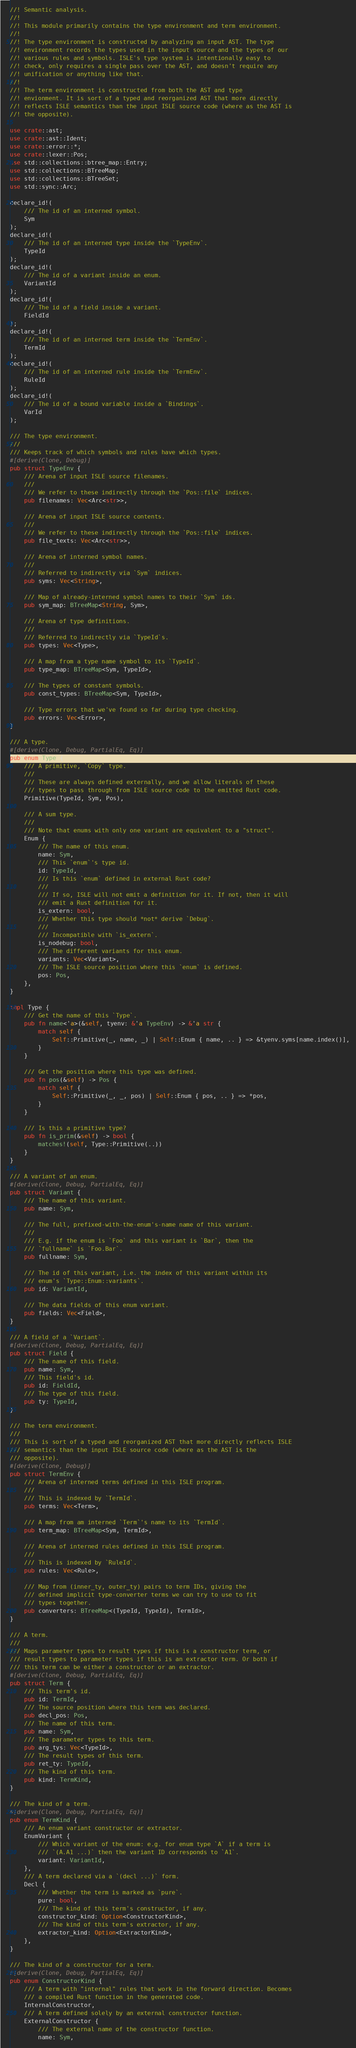Convert code to text. <code><loc_0><loc_0><loc_500><loc_500><_Rust_>//! Semantic analysis.
//!
//! This module primarily contains the type environment and term environment.
//!
//! The type environment is constructed by analyzing an input AST. The type
//! environment records the types used in the input source and the types of our
//! various rules and symbols. ISLE's type system is intentionally easy to
//! check, only requires a single pass over the AST, and doesn't require any
//! unification or anything like that.
//!
//! The term environment is constructed from both the AST and type
//! envionment. It is sort of a typed and reorganized AST that more directly
//! reflects ISLE semantics than the input ISLE source code (where as the AST is
//! the opposite).

use crate::ast;
use crate::ast::Ident;
use crate::error::*;
use crate::lexer::Pos;
use std::collections::btree_map::Entry;
use std::collections::BTreeMap;
use std::collections::BTreeSet;
use std::sync::Arc;

declare_id!(
    /// The id of an interned symbol.
    Sym
);
declare_id!(
    /// The id of an interned type inside the `TypeEnv`.
    TypeId
);
declare_id!(
    /// The id of a variant inside an enum.
    VariantId
);
declare_id!(
    /// The id of a field inside a variant.
    FieldId
);
declare_id!(
    /// The id of an interned term inside the `TermEnv`.
    TermId
);
declare_id!(
    /// The id of an interned rule inside the `TermEnv`.
    RuleId
);
declare_id!(
    /// The id of a bound variable inside a `Bindings`.
    VarId
);

/// The type environment.
///
/// Keeps track of which symbols and rules have which types.
#[derive(Clone, Debug)]
pub struct TypeEnv {
    /// Arena of input ISLE source filenames.
    ///
    /// We refer to these indirectly through the `Pos::file` indices.
    pub filenames: Vec<Arc<str>>,

    /// Arena of input ISLE source contents.
    ///
    /// We refer to these indirectly through the `Pos::file` indices.
    pub file_texts: Vec<Arc<str>>,

    /// Arena of interned symbol names.
    ///
    /// Referred to indirectly via `Sym` indices.
    pub syms: Vec<String>,

    /// Map of already-interned symbol names to their `Sym` ids.
    pub sym_map: BTreeMap<String, Sym>,

    /// Arena of type definitions.
    ///
    /// Referred to indirectly via `TypeId`s.
    pub types: Vec<Type>,

    /// A map from a type name symbol to its `TypeId`.
    pub type_map: BTreeMap<Sym, TypeId>,

    /// The types of constant symbols.
    pub const_types: BTreeMap<Sym, TypeId>,

    /// Type errors that we've found so far during type checking.
    pub errors: Vec<Error>,
}

/// A type.
#[derive(Clone, Debug, PartialEq, Eq)]
pub enum Type {
    /// A primitive, `Copy` type.
    ///
    /// These are always defined externally, and we allow literals of these
    /// types to pass through from ISLE source code to the emitted Rust code.
    Primitive(TypeId, Sym, Pos),

    /// A sum type.
    ///
    /// Note that enums with only one variant are equivalent to a "struct".
    Enum {
        /// The name of this enum.
        name: Sym,
        /// This `enum`'s type id.
        id: TypeId,
        /// Is this `enum` defined in external Rust code?
        ///
        /// If so, ISLE will not emit a definition for it. If not, then it will
        /// emit a Rust definition for it.
        is_extern: bool,
        /// Whether this type should *not* derive `Debug`.
        ///
        /// Incompatible with `is_extern`.
        is_nodebug: bool,
        /// The different variants for this enum.
        variants: Vec<Variant>,
        /// The ISLE source position where this `enum` is defined.
        pos: Pos,
    },
}

impl Type {
    /// Get the name of this `Type`.
    pub fn name<'a>(&self, tyenv: &'a TypeEnv) -> &'a str {
        match self {
            Self::Primitive(_, name, _) | Self::Enum { name, .. } => &tyenv.syms[name.index()],
        }
    }

    /// Get the position where this type was defined.
    pub fn pos(&self) -> Pos {
        match self {
            Self::Primitive(_, _, pos) | Self::Enum { pos, .. } => *pos,
        }
    }

    /// Is this a primitive type?
    pub fn is_prim(&self) -> bool {
        matches!(self, Type::Primitive(..))
    }
}

/// A variant of an enum.
#[derive(Clone, Debug, PartialEq, Eq)]
pub struct Variant {
    /// The name of this variant.
    pub name: Sym,

    /// The full, prefixed-with-the-enum's-name name of this variant.
    ///
    /// E.g. if the enum is `Foo` and this variant is `Bar`, then the
    /// `fullname` is `Foo.Bar`.
    pub fullname: Sym,

    /// The id of this variant, i.e. the index of this variant within its
    /// enum's `Type::Enum::variants`.
    pub id: VariantId,

    /// The data fields of this enum variant.
    pub fields: Vec<Field>,
}

/// A field of a `Variant`.
#[derive(Clone, Debug, PartialEq, Eq)]
pub struct Field {
    /// The name of this field.
    pub name: Sym,
    /// This field's id.
    pub id: FieldId,
    /// The type of this field.
    pub ty: TypeId,
}

/// The term environment.
///
/// This is sort of a typed and reorganized AST that more directly reflects ISLE
/// semantics than the input ISLE source code (where as the AST is the
/// opposite).
#[derive(Clone, Debug)]
pub struct TermEnv {
    /// Arena of interned terms defined in this ISLE program.
    ///
    /// This is indexed by `TermId`.
    pub terms: Vec<Term>,

    /// A map from am interned `Term`'s name to its `TermId`.
    pub term_map: BTreeMap<Sym, TermId>,

    /// Arena of interned rules defined in this ISLE program.
    ///
    /// This is indexed by `RuleId`.
    pub rules: Vec<Rule>,

    /// Map from (inner_ty, outer_ty) pairs to term IDs, giving the
    /// defined implicit type-converter terms we can try to use to fit
    /// types together.
    pub converters: BTreeMap<(TypeId, TypeId), TermId>,
}

/// A term.
///
/// Maps parameter types to result types if this is a constructor term, or
/// result types to parameter types if this is an extractor term. Or both if
/// this term can be either a constructor or an extractor.
#[derive(Clone, Debug, PartialEq, Eq)]
pub struct Term {
    /// This term's id.
    pub id: TermId,
    /// The source position where this term was declared.
    pub decl_pos: Pos,
    /// The name of this term.
    pub name: Sym,
    /// The parameter types to this term.
    pub arg_tys: Vec<TypeId>,
    /// The result types of this term.
    pub ret_ty: TypeId,
    /// The kind of this term.
    pub kind: TermKind,
}

/// The kind of a term.
#[derive(Clone, Debug, PartialEq, Eq)]
pub enum TermKind {
    /// An enum variant constructor or extractor.
    EnumVariant {
        /// Which variant of the enum: e.g. for enum type `A` if a term is
        /// `(A.A1 ...)` then the variant ID corresponds to `A1`.
        variant: VariantId,
    },
    /// A term declared via a `(decl ...)` form.
    Decl {
        /// Whether the term is marked as `pure`.
        pure: bool,
        /// The kind of this term's constructor, if any.
        constructor_kind: Option<ConstructorKind>,
        /// The kind of this term's extractor, if any.
        extractor_kind: Option<ExtractorKind>,
    },
}

/// The kind of a constructor for a term.
#[derive(Clone, Debug, PartialEq, Eq)]
pub enum ConstructorKind {
    /// A term with "internal" rules that work in the forward direction. Becomes
    /// a compiled Rust function in the generated code.
    InternalConstructor,
    /// A term defined solely by an external constructor function.
    ExternalConstructor {
        /// The external name of the constructor function.
        name: Sym,</code> 